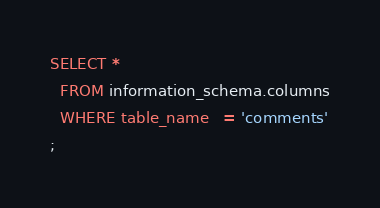<code> <loc_0><loc_0><loc_500><loc_500><_SQL_>SELECT *
  FROM information_schema.columns
  WHERE table_name   = 'comments'
;</code> 